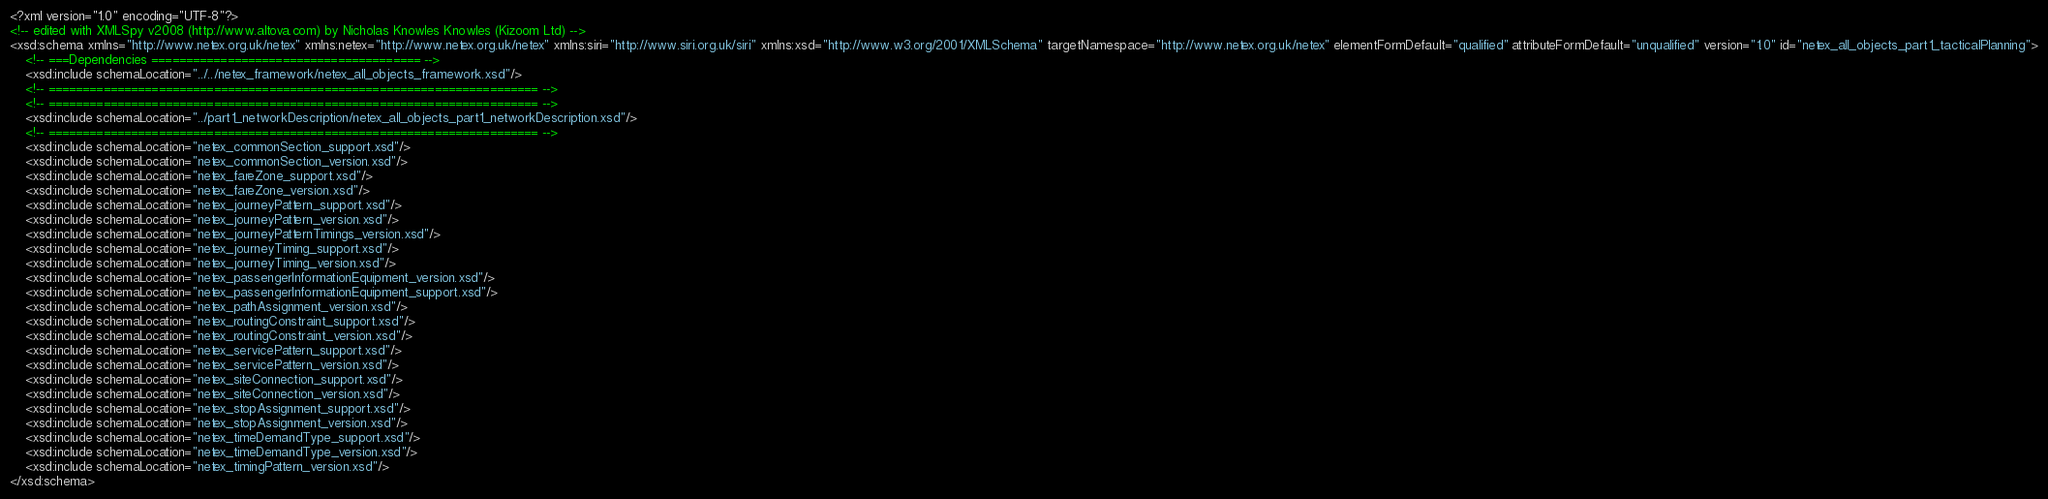Convert code to text. <code><loc_0><loc_0><loc_500><loc_500><_XML_><?xml version="1.0" encoding="UTF-8"?>
<!-- edited with XMLSpy v2008 (http://www.altova.com) by Nicholas Knowles Knowles (Kizoom Ltd) -->
<xsd:schema xmlns="http://www.netex.org.uk/netex" xmlns:netex="http://www.netex.org.uk/netex" xmlns:siri="http://www.siri.org.uk/siri" xmlns:xsd="http://www.w3.org/2001/XMLSchema" targetNamespace="http://www.netex.org.uk/netex" elementFormDefault="qualified" attributeFormDefault="unqualified" version="1.0" id="netex_all_objects_part1_tacticalPlanning">
	<!-- ===Dependencies ======================================= -->
	<xsd:include schemaLocation="../../netex_framework/netex_all_objects_framework.xsd"/>
	<!-- ======================================================================= -->
	<!-- ======================================================================= -->
	<xsd:include schemaLocation="../part1_networkDescription/netex_all_objects_part1_networkDescription.xsd"/>
	<!-- ======================================================================= -->
	<xsd:include schemaLocation="netex_commonSection_support.xsd"/>
	<xsd:include schemaLocation="netex_commonSection_version.xsd"/>
	<xsd:include schemaLocation="netex_fareZone_support.xsd"/>
	<xsd:include schemaLocation="netex_fareZone_version.xsd"/>
	<xsd:include schemaLocation="netex_journeyPattern_support.xsd"/>
	<xsd:include schemaLocation="netex_journeyPattern_version.xsd"/>
	<xsd:include schemaLocation="netex_journeyPatternTimings_version.xsd"/>
	<xsd:include schemaLocation="netex_journeyTiming_support.xsd"/>
	<xsd:include schemaLocation="netex_journeyTiming_version.xsd"/>
	<xsd:include schemaLocation="netex_passengerInformationEquipment_version.xsd"/>
	<xsd:include schemaLocation="netex_passengerInformationEquipment_support.xsd"/>
	<xsd:include schemaLocation="netex_pathAssignment_version.xsd"/>
	<xsd:include schemaLocation="netex_routingConstraint_support.xsd"/>
	<xsd:include schemaLocation="netex_routingConstraint_version.xsd"/>
	<xsd:include schemaLocation="netex_servicePattern_support.xsd"/>
	<xsd:include schemaLocation="netex_servicePattern_version.xsd"/>
	<xsd:include schemaLocation="netex_siteConnection_support.xsd"/>
	<xsd:include schemaLocation="netex_siteConnection_version.xsd"/>
	<xsd:include schemaLocation="netex_stopAssignment_support.xsd"/>
	<xsd:include schemaLocation="netex_stopAssignment_version.xsd"/>
	<xsd:include schemaLocation="netex_timeDemandType_support.xsd"/>
	<xsd:include schemaLocation="netex_timeDemandType_version.xsd"/>
	<xsd:include schemaLocation="netex_timingPattern_version.xsd"/>
</xsd:schema>
</code> 